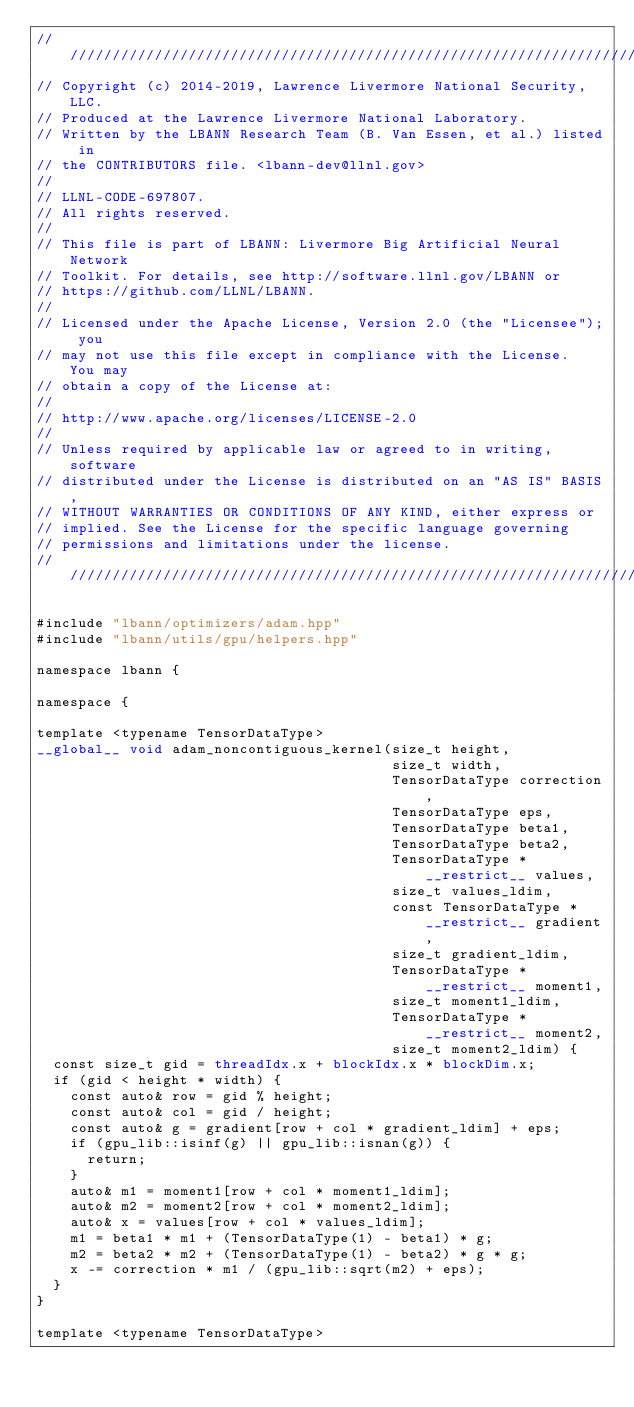Convert code to text. <code><loc_0><loc_0><loc_500><loc_500><_Cuda_>////////////////////////////////////////////////////////////////////////////////
// Copyright (c) 2014-2019, Lawrence Livermore National Security, LLC.
// Produced at the Lawrence Livermore National Laboratory.
// Written by the LBANN Research Team (B. Van Essen, et al.) listed in
// the CONTRIBUTORS file. <lbann-dev@llnl.gov>
//
// LLNL-CODE-697807.
// All rights reserved.
//
// This file is part of LBANN: Livermore Big Artificial Neural Network
// Toolkit. For details, see http://software.llnl.gov/LBANN or
// https://github.com/LLNL/LBANN.
//
// Licensed under the Apache License, Version 2.0 (the "Licensee"); you
// may not use this file except in compliance with the License.  You may
// obtain a copy of the License at:
//
// http://www.apache.org/licenses/LICENSE-2.0
//
// Unless required by applicable law or agreed to in writing, software
// distributed under the License is distributed on an "AS IS" BASIS,
// WITHOUT WARRANTIES OR CONDITIONS OF ANY KIND, either express or
// implied. See the License for the specific language governing
// permissions and limitations under the license.
////////////////////////////////////////////////////////////////////////////////

#include "lbann/optimizers/adam.hpp"
#include "lbann/utils/gpu/helpers.hpp"

namespace lbann {

namespace {

template <typename TensorDataType>
__global__ void adam_noncontiguous_kernel(size_t height,
                                          size_t width,
                                          TensorDataType correction,
                                          TensorDataType eps,
                                          TensorDataType beta1,
                                          TensorDataType beta2,
                                          TensorDataType * __restrict__ values,
                                          size_t values_ldim,
                                          const TensorDataType * __restrict__ gradient,
                                          size_t gradient_ldim,
                                          TensorDataType * __restrict__ moment1,
                                          size_t moment1_ldim,
                                          TensorDataType * __restrict__ moment2,
                                          size_t moment2_ldim) {
  const size_t gid = threadIdx.x + blockIdx.x * blockDim.x;
  if (gid < height * width) {
    const auto& row = gid % height;
    const auto& col = gid / height;
    const auto& g = gradient[row + col * gradient_ldim] + eps;
    if (gpu_lib::isinf(g) || gpu_lib::isnan(g)) {
      return;
    }
    auto& m1 = moment1[row + col * moment1_ldim];
    auto& m2 = moment2[row + col * moment2_ldim];
    auto& x = values[row + col * values_ldim];
    m1 = beta1 * m1 + (TensorDataType(1) - beta1) * g;
    m2 = beta2 * m2 + (TensorDataType(1) - beta2) * g * g;
    x -= correction * m1 / (gpu_lib::sqrt(m2) + eps);
  }
}

template <typename TensorDataType></code> 